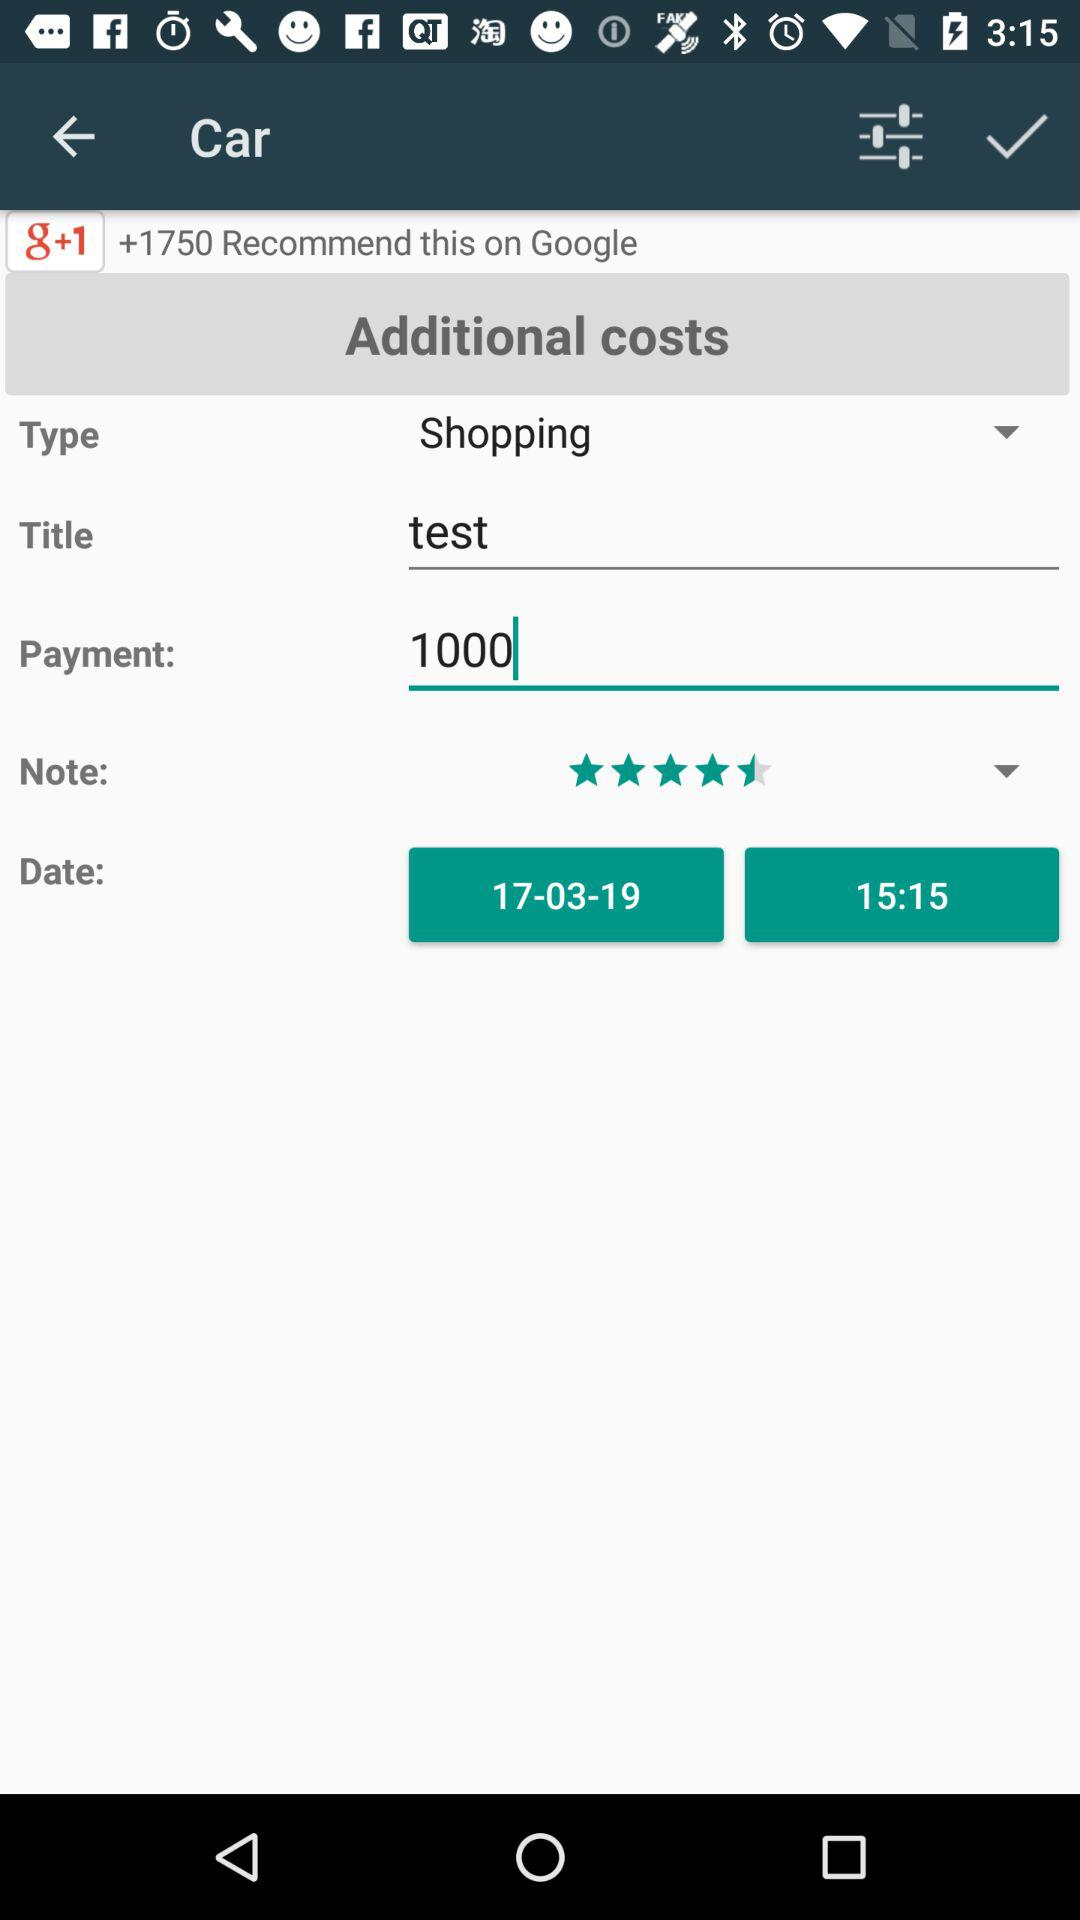Which time is selected? The selected time is 15:15. 